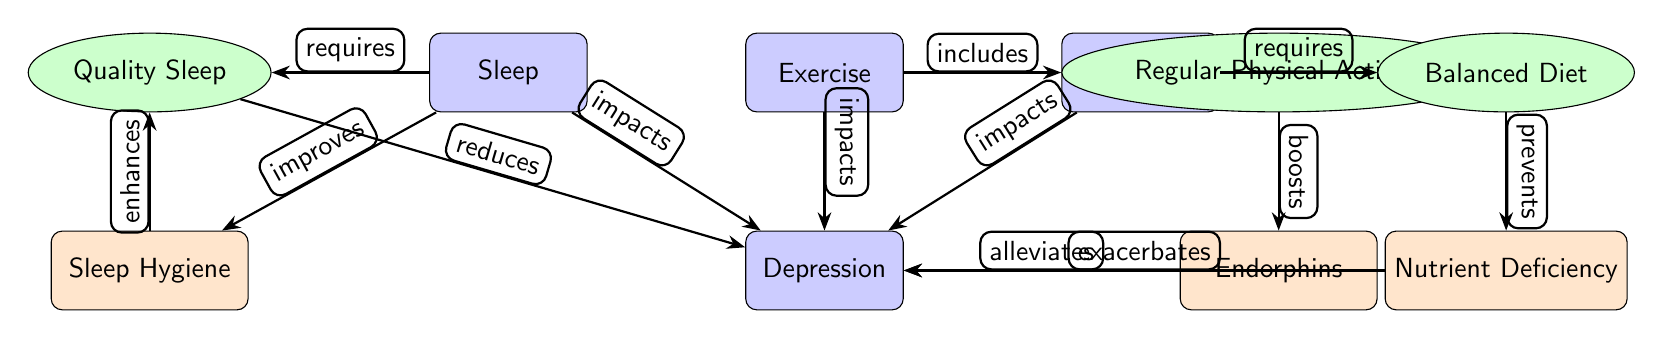What are the three main lifestyle factors impacting depression? The diagram lists three main lifestyle factors affecting depression which are Sleep, Exercise, and Nutrition, as represented by the main nodes above the Depression node.
Answer: Sleep, Exercise, Nutrition How does Quality Sleep affect Depression? The diagram shows that Quality Sleep reduces Depression, indicating a direct positive effect on mental health.
Answer: Reduces What is the relationship between Exercise and Endorphins? The diagram indicates that Regular Physical Activity (associated with Exercise) boosts Endorphins, which contributes to alleviating Depression.
Answer: Boosts Which factor is associated with Nutrition in preventing something related to Depression? Based on the diagram, Balanced Diet is connected to preventing Nutrient Deficiency, which in turn exacerbates Depression.
Answer: Prevents What node directly affects Sleep Hygiene? The diagram shows that Sleep enhances Sleep Hygiene, indicating an improvement in sleep-related practices.
Answer: Enhances How many nodes are there in total in this diagram? By counting all the main, factor, and effect nodes in the diagram, we see there are 7 nodes in total.
Answer: 7 What effect does Nutrient Deficiency have on Depression? The diagram states that Nutrient Deficiency exacerbates Depression, implying a negative relationship where deficiency worsens mental health.
Answer: Exacerbates What is required for Regular Physical Activity according to the diagram? The diagram clearly states that Regular Physical Activity requires Exercise as a main factor, showing their direct connection.
Answer: Requires What is indicated as improving the Quality Sleep? The diagram suggests that Sleep Hygiene is improved by Sleep, thus fostering better quality of sleep.
Answer: Improves 